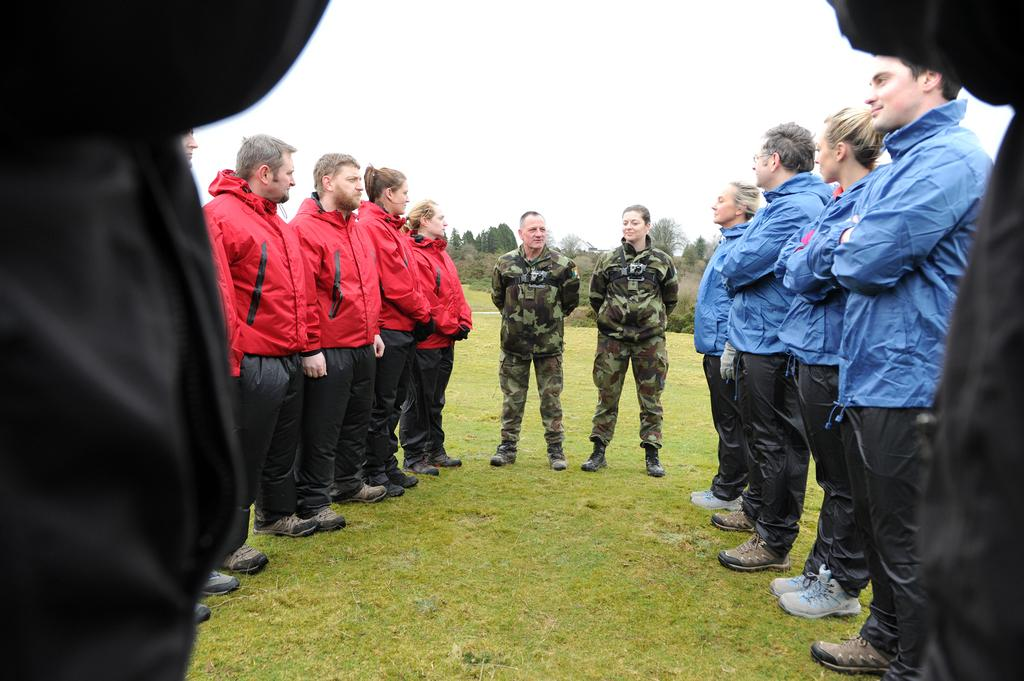How many people are in the image? There is a group of people in the image, but the exact number cannot be determined from the provided facts. What are the people in the image doing? The people are on the ground, but their specific activity is not mentioned in the facts. What can be seen in the background of the image? There are trees and the sky visible in the background of the image. What word is being used by the goose in the image? There is no goose present in the image, so it is not possible to determine what word might be used by a goose. 